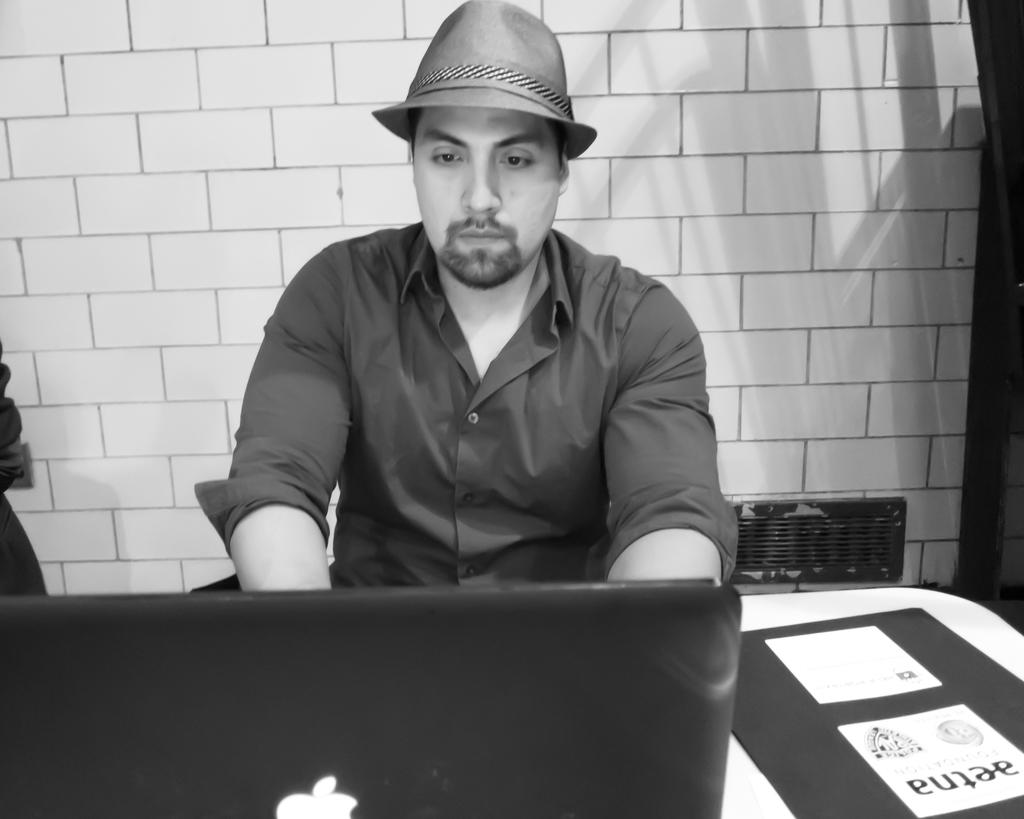What is the man in the image doing? The man is sitting and working on a laptop. What is the man wearing in the image? The man is wearing a shirt and a cap. What can be seen in the background of the image? There is a wall visible in the background of the image. How does the man's sock feel in the image? There is no mention of a sock in the image, so it is impossible to determine how it feels. Can you describe the robin's nest in the image? There is no robin or nest present in the image. 